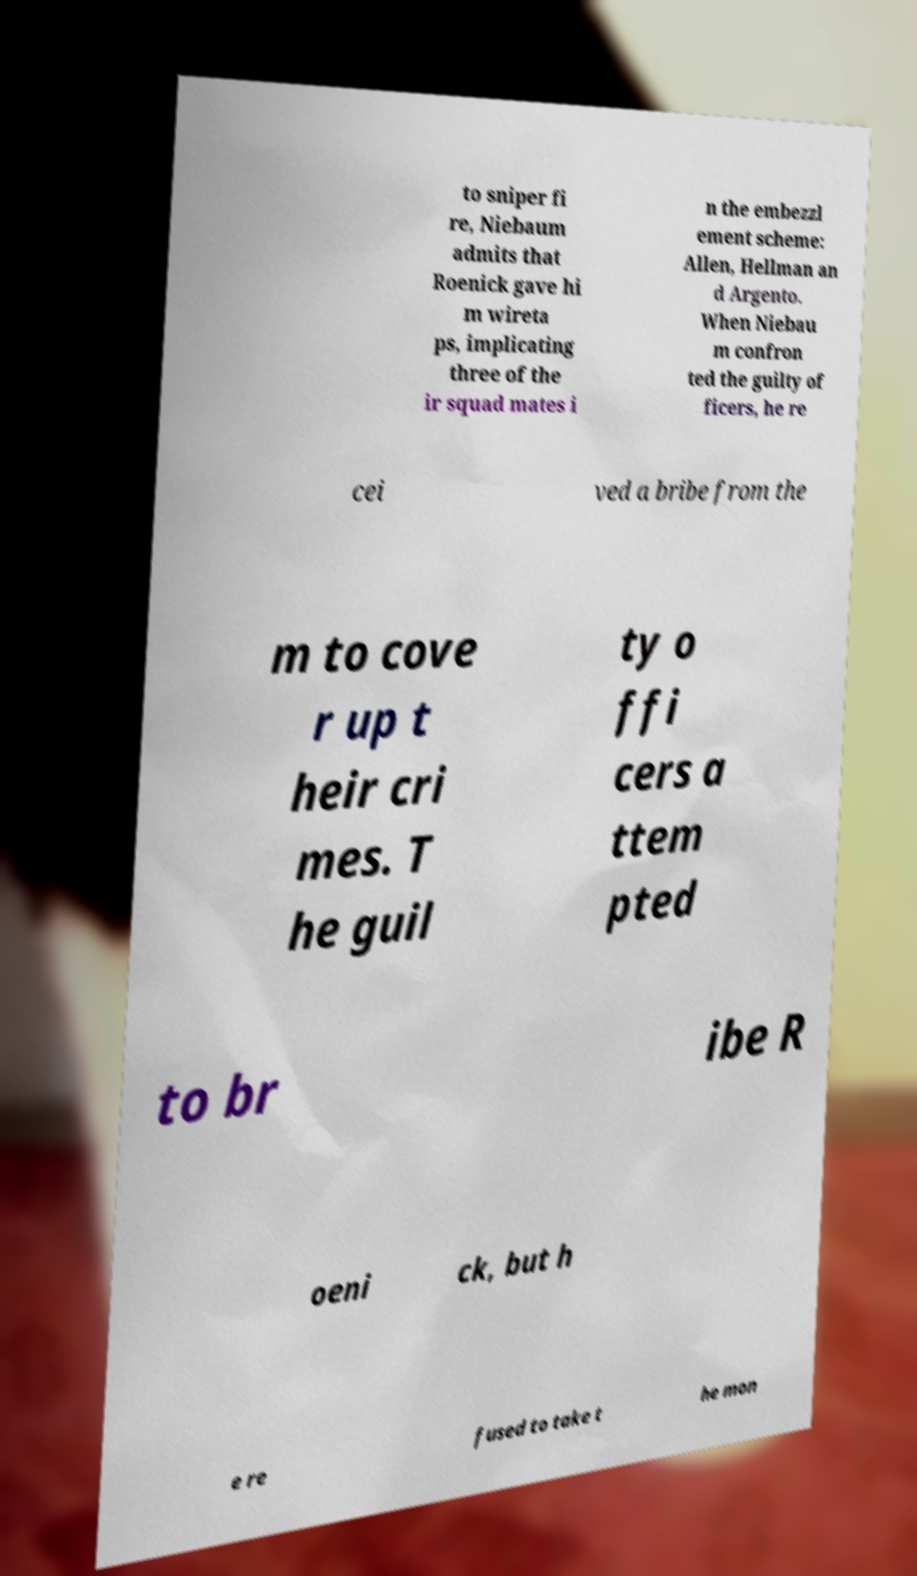Can you accurately transcribe the text from the provided image for me? to sniper fi re, Niebaum admits that Roenick gave hi m wireta ps, implicating three of the ir squad mates i n the embezzl ement scheme: Allen, Hellman an d Argento. When Niebau m confron ted the guilty of ficers, he re cei ved a bribe from the m to cove r up t heir cri mes. T he guil ty o ffi cers a ttem pted to br ibe R oeni ck, but h e re fused to take t he mon 